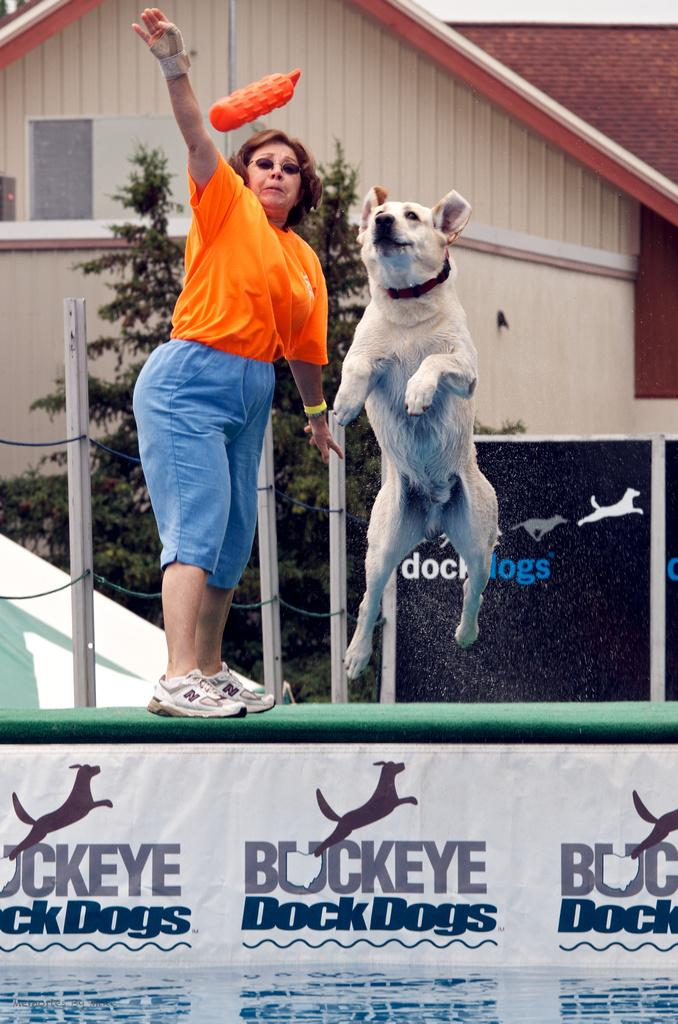What is the main subject of the image? The main subject of the image is a woman. What is the woman doing in the image? The woman is standing and throwing something into the air. What is the dog doing in the image? The dog is jumping to hold the object thrown by the woman. What can be seen in the background of the image? There is a building in the background of the image. What type of answer can be seen on the table in the image? There is no table present in the image, and therefore no answer can be seen. 